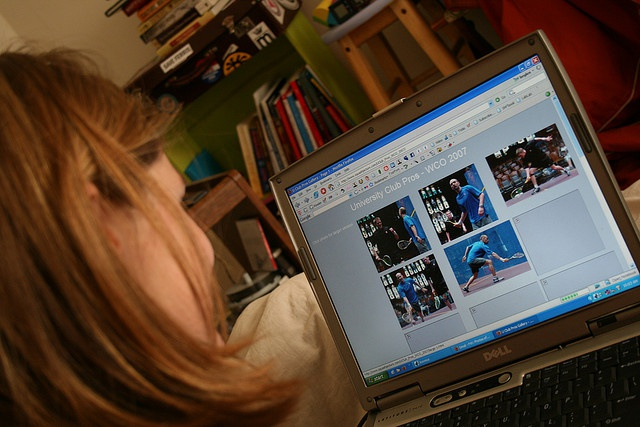Describe the objects in this image and their specific colors. I can see laptop in olive, black, darkgray, maroon, and gray tones, people in olive, maroon, black, and brown tones, chair in olive, black, and maroon tones, book in olive, maroon, and black tones, and book in olive, maroon, black, and gray tones in this image. 